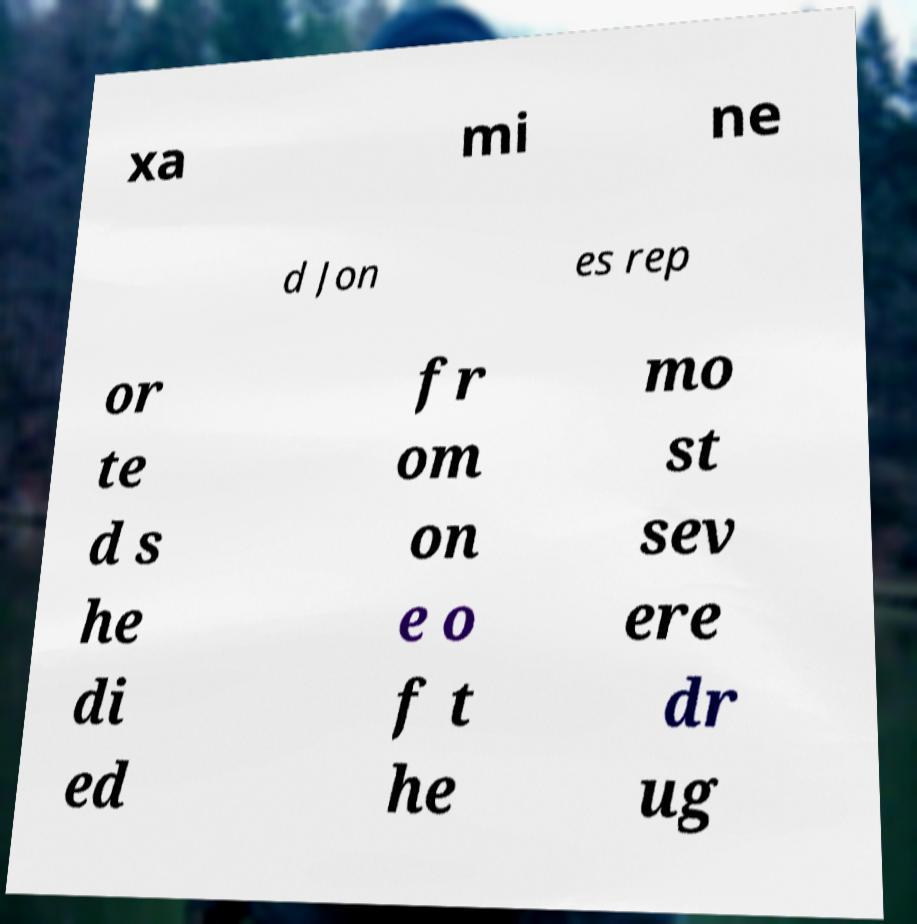Could you extract and type out the text from this image? xa mi ne d Jon es rep or te d s he di ed fr om on e o f t he mo st sev ere dr ug 